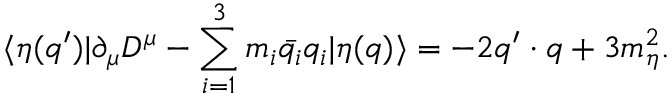<formula> <loc_0><loc_0><loc_500><loc_500>\langle \eta ( q ^ { \prime } ) | \partial _ { \mu } D ^ { \mu } - \sum _ { i = 1 } ^ { 3 } m _ { i } \bar { q _ { i } } q _ { i } | \eta ( q ) \rangle = - 2 q ^ { \prime } \cdot q + 3 m _ { \eta } ^ { 2 } .</formula> 